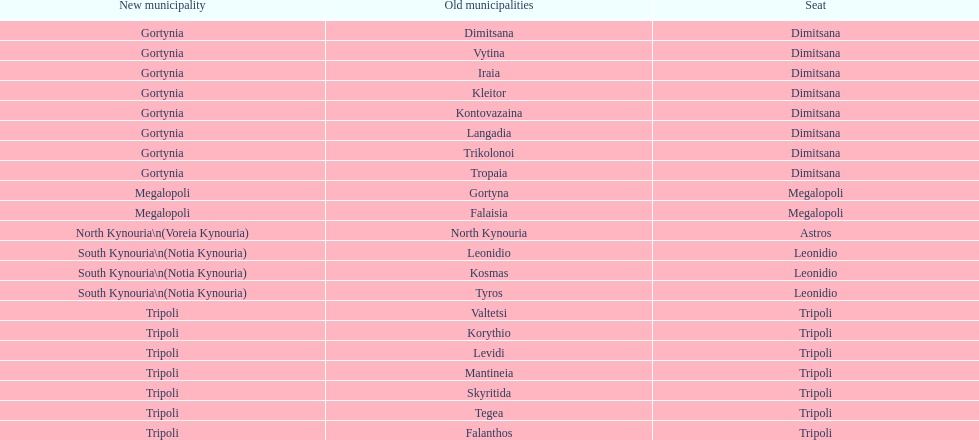Can you parse all the data within this table? {'header': ['New municipality', 'Old municipalities', 'Seat'], 'rows': [['Gortynia', 'Dimitsana', 'Dimitsana'], ['Gortynia', 'Vytina', 'Dimitsana'], ['Gortynia', 'Iraia', 'Dimitsana'], ['Gortynia', 'Kleitor', 'Dimitsana'], ['Gortynia', 'Kontovazaina', 'Dimitsana'], ['Gortynia', 'Langadia', 'Dimitsana'], ['Gortynia', 'Trikolonoi', 'Dimitsana'], ['Gortynia', 'Tropaia', 'Dimitsana'], ['Megalopoli', 'Gortyna', 'Megalopoli'], ['Megalopoli', 'Falaisia', 'Megalopoli'], ['North Kynouria\\n(Voreia Kynouria)', 'North Kynouria', 'Astros'], ['South Kynouria\\n(Notia Kynouria)', 'Leonidio', 'Leonidio'], ['South Kynouria\\n(Notia Kynouria)', 'Kosmas', 'Leonidio'], ['South Kynouria\\n(Notia Kynouria)', 'Tyros', 'Leonidio'], ['Tripoli', 'Valtetsi', 'Tripoli'], ['Tripoli', 'Korythio', 'Tripoli'], ['Tripoli', 'Levidi', 'Tripoli'], ['Tripoli', 'Mantineia', 'Tripoli'], ['Tripoli', 'Skyritida', 'Tripoli'], ['Tripoli', 'Tegea', 'Tripoli'], ['Tripoli', 'Falanthos', 'Tripoli']]} Is tripoli still considered a municipality in arcadia since its 2011 reformation? Yes. 